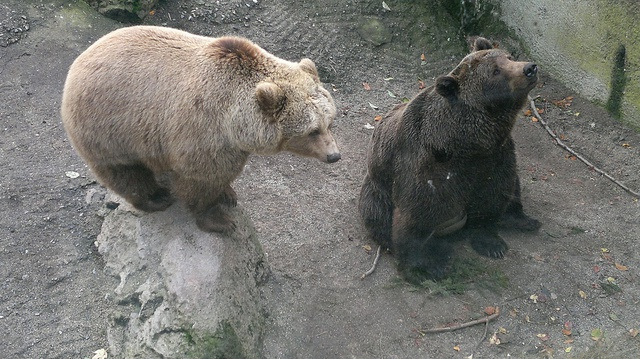Describe the objects in this image and their specific colors. I can see bear in gray, darkgray, and black tones and bear in gray, black, and darkgray tones in this image. 